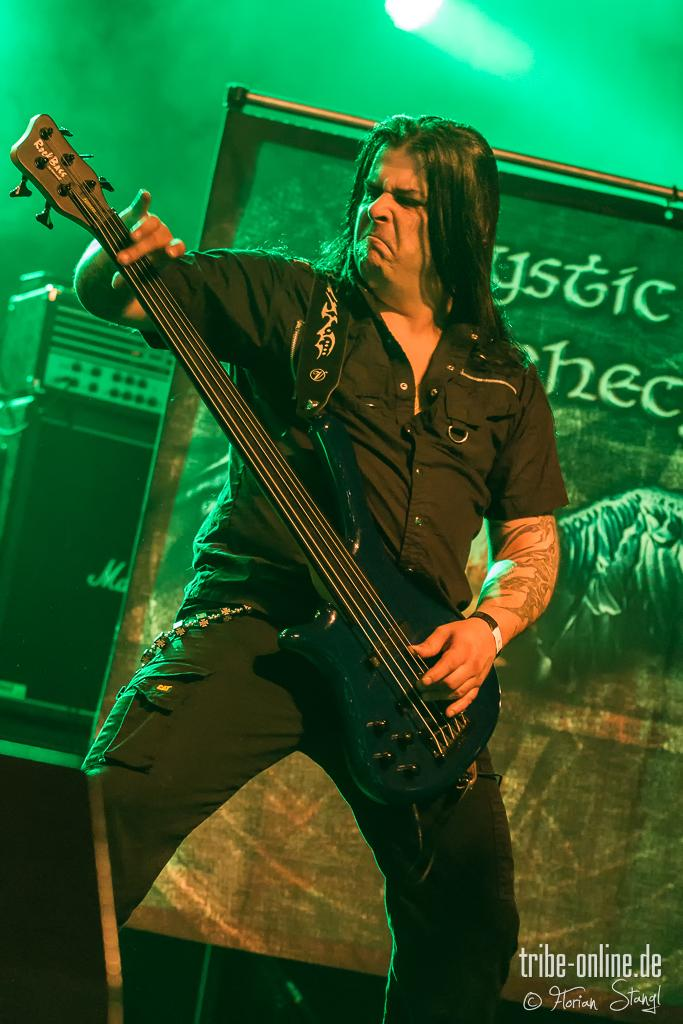Who is the main subject in the image? There is a person in the center of the image. What is the person holding in the image? The person is holding a guitar. What can be seen in the background of the image? There is a banner in the background of the image. What is written or depicted at the bottom of the image? There is text at the bottom of the image. How many squirrels are playing with the guitar in the image? There are no squirrels present in the image, and the guitar is being held by the person. What type of waste is visible in the image? There is no waste visible in the image; it features a person holding a guitar, a banner in the background, and text at the bottom. 